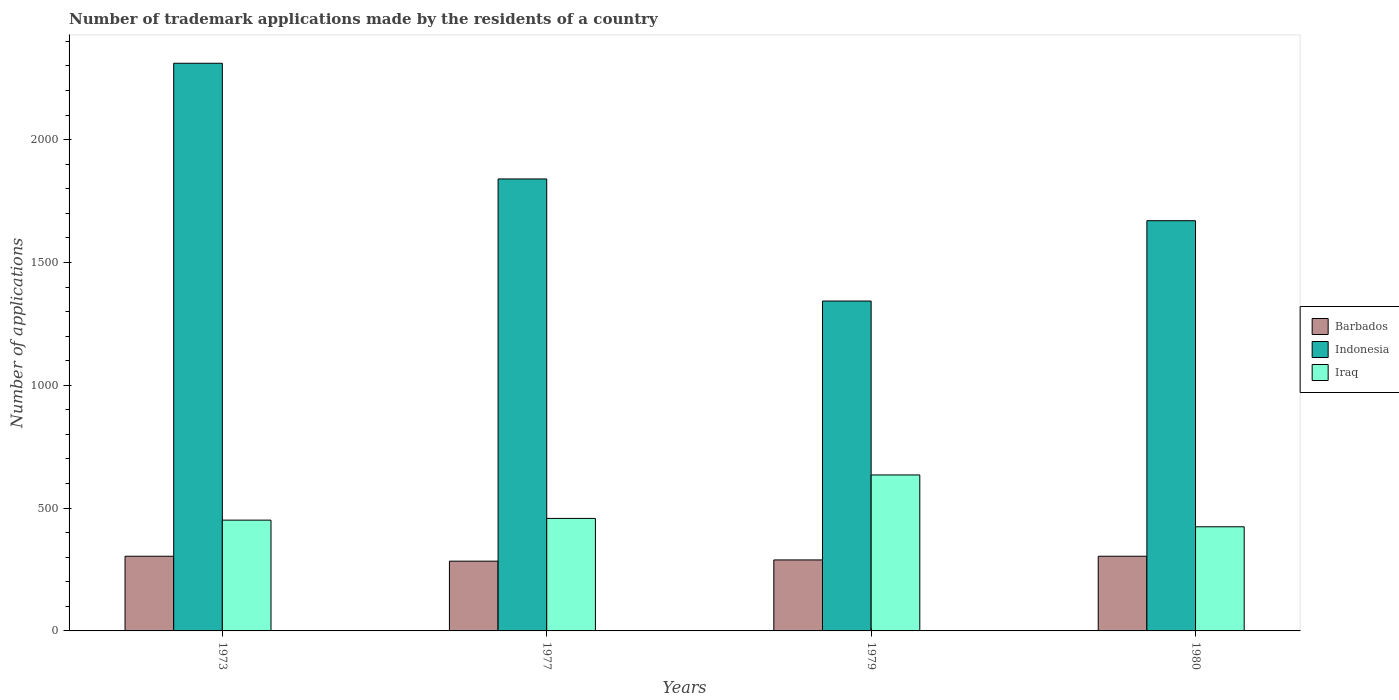How many different coloured bars are there?
Offer a terse response. 3. Are the number of bars on each tick of the X-axis equal?
Provide a succinct answer. Yes. How many bars are there on the 1st tick from the left?
Your answer should be very brief. 3. How many bars are there on the 1st tick from the right?
Keep it short and to the point. 3. What is the label of the 4th group of bars from the left?
Make the answer very short. 1980. What is the number of trademark applications made by the residents in Barbados in 1979?
Provide a succinct answer. 289. Across all years, what is the maximum number of trademark applications made by the residents in Indonesia?
Offer a very short reply. 2311. Across all years, what is the minimum number of trademark applications made by the residents in Indonesia?
Your response must be concise. 1343. In which year was the number of trademark applications made by the residents in Iraq maximum?
Your response must be concise. 1979. What is the total number of trademark applications made by the residents in Iraq in the graph?
Keep it short and to the point. 1968. What is the difference between the number of trademark applications made by the residents in Indonesia in 1977 and that in 1979?
Your answer should be very brief. 497. What is the difference between the number of trademark applications made by the residents in Indonesia in 1977 and the number of trademark applications made by the residents in Barbados in 1973?
Give a very brief answer. 1536. What is the average number of trademark applications made by the residents in Indonesia per year?
Offer a very short reply. 1791. In the year 1973, what is the difference between the number of trademark applications made by the residents in Indonesia and number of trademark applications made by the residents in Barbados?
Ensure brevity in your answer.  2007. In how many years, is the number of trademark applications made by the residents in Iraq greater than 1500?
Keep it short and to the point. 0. What is the ratio of the number of trademark applications made by the residents in Iraq in 1973 to that in 1979?
Provide a succinct answer. 0.71. What is the difference between the highest and the second highest number of trademark applications made by the residents in Indonesia?
Ensure brevity in your answer.  471. What is the difference between the highest and the lowest number of trademark applications made by the residents in Barbados?
Make the answer very short. 20. In how many years, is the number of trademark applications made by the residents in Indonesia greater than the average number of trademark applications made by the residents in Indonesia taken over all years?
Provide a succinct answer. 2. What does the 3rd bar from the left in 1980 represents?
Provide a succinct answer. Iraq. Are all the bars in the graph horizontal?
Your answer should be very brief. No. How many years are there in the graph?
Provide a short and direct response. 4. What is the difference between two consecutive major ticks on the Y-axis?
Ensure brevity in your answer.  500. Are the values on the major ticks of Y-axis written in scientific E-notation?
Your answer should be very brief. No. How many legend labels are there?
Your answer should be very brief. 3. What is the title of the graph?
Offer a terse response. Number of trademark applications made by the residents of a country. Does "Micronesia" appear as one of the legend labels in the graph?
Provide a succinct answer. No. What is the label or title of the Y-axis?
Offer a very short reply. Number of applications. What is the Number of applications of Barbados in 1973?
Your answer should be very brief. 304. What is the Number of applications of Indonesia in 1973?
Provide a succinct answer. 2311. What is the Number of applications of Iraq in 1973?
Provide a succinct answer. 451. What is the Number of applications of Barbados in 1977?
Your answer should be compact. 284. What is the Number of applications of Indonesia in 1977?
Ensure brevity in your answer.  1840. What is the Number of applications in Iraq in 1977?
Offer a terse response. 458. What is the Number of applications of Barbados in 1979?
Offer a terse response. 289. What is the Number of applications of Indonesia in 1979?
Your answer should be very brief. 1343. What is the Number of applications of Iraq in 1979?
Keep it short and to the point. 635. What is the Number of applications in Barbados in 1980?
Your answer should be compact. 304. What is the Number of applications of Indonesia in 1980?
Give a very brief answer. 1670. What is the Number of applications in Iraq in 1980?
Offer a terse response. 424. Across all years, what is the maximum Number of applications of Barbados?
Your answer should be compact. 304. Across all years, what is the maximum Number of applications in Indonesia?
Give a very brief answer. 2311. Across all years, what is the maximum Number of applications of Iraq?
Provide a short and direct response. 635. Across all years, what is the minimum Number of applications in Barbados?
Give a very brief answer. 284. Across all years, what is the minimum Number of applications of Indonesia?
Ensure brevity in your answer.  1343. Across all years, what is the minimum Number of applications in Iraq?
Keep it short and to the point. 424. What is the total Number of applications in Barbados in the graph?
Give a very brief answer. 1181. What is the total Number of applications of Indonesia in the graph?
Offer a terse response. 7164. What is the total Number of applications of Iraq in the graph?
Your answer should be compact. 1968. What is the difference between the Number of applications of Indonesia in 1973 and that in 1977?
Your answer should be very brief. 471. What is the difference between the Number of applications of Iraq in 1973 and that in 1977?
Make the answer very short. -7. What is the difference between the Number of applications in Indonesia in 1973 and that in 1979?
Ensure brevity in your answer.  968. What is the difference between the Number of applications of Iraq in 1973 and that in 1979?
Ensure brevity in your answer.  -184. What is the difference between the Number of applications in Indonesia in 1973 and that in 1980?
Your response must be concise. 641. What is the difference between the Number of applications in Barbados in 1977 and that in 1979?
Your answer should be very brief. -5. What is the difference between the Number of applications of Indonesia in 1977 and that in 1979?
Your answer should be very brief. 497. What is the difference between the Number of applications in Iraq in 1977 and that in 1979?
Keep it short and to the point. -177. What is the difference between the Number of applications in Indonesia in 1977 and that in 1980?
Make the answer very short. 170. What is the difference between the Number of applications in Barbados in 1979 and that in 1980?
Your answer should be very brief. -15. What is the difference between the Number of applications of Indonesia in 1979 and that in 1980?
Your response must be concise. -327. What is the difference between the Number of applications in Iraq in 1979 and that in 1980?
Give a very brief answer. 211. What is the difference between the Number of applications in Barbados in 1973 and the Number of applications in Indonesia in 1977?
Ensure brevity in your answer.  -1536. What is the difference between the Number of applications of Barbados in 1973 and the Number of applications of Iraq in 1977?
Ensure brevity in your answer.  -154. What is the difference between the Number of applications of Indonesia in 1973 and the Number of applications of Iraq in 1977?
Provide a short and direct response. 1853. What is the difference between the Number of applications of Barbados in 1973 and the Number of applications of Indonesia in 1979?
Make the answer very short. -1039. What is the difference between the Number of applications of Barbados in 1973 and the Number of applications of Iraq in 1979?
Make the answer very short. -331. What is the difference between the Number of applications in Indonesia in 1973 and the Number of applications in Iraq in 1979?
Your answer should be compact. 1676. What is the difference between the Number of applications of Barbados in 1973 and the Number of applications of Indonesia in 1980?
Provide a succinct answer. -1366. What is the difference between the Number of applications in Barbados in 1973 and the Number of applications in Iraq in 1980?
Offer a terse response. -120. What is the difference between the Number of applications of Indonesia in 1973 and the Number of applications of Iraq in 1980?
Offer a terse response. 1887. What is the difference between the Number of applications of Barbados in 1977 and the Number of applications of Indonesia in 1979?
Offer a very short reply. -1059. What is the difference between the Number of applications of Barbados in 1977 and the Number of applications of Iraq in 1979?
Your response must be concise. -351. What is the difference between the Number of applications of Indonesia in 1977 and the Number of applications of Iraq in 1979?
Keep it short and to the point. 1205. What is the difference between the Number of applications in Barbados in 1977 and the Number of applications in Indonesia in 1980?
Offer a very short reply. -1386. What is the difference between the Number of applications of Barbados in 1977 and the Number of applications of Iraq in 1980?
Your response must be concise. -140. What is the difference between the Number of applications in Indonesia in 1977 and the Number of applications in Iraq in 1980?
Your response must be concise. 1416. What is the difference between the Number of applications in Barbados in 1979 and the Number of applications in Indonesia in 1980?
Ensure brevity in your answer.  -1381. What is the difference between the Number of applications in Barbados in 1979 and the Number of applications in Iraq in 1980?
Offer a very short reply. -135. What is the difference between the Number of applications in Indonesia in 1979 and the Number of applications in Iraq in 1980?
Make the answer very short. 919. What is the average Number of applications in Barbados per year?
Ensure brevity in your answer.  295.25. What is the average Number of applications in Indonesia per year?
Give a very brief answer. 1791. What is the average Number of applications in Iraq per year?
Your answer should be compact. 492. In the year 1973, what is the difference between the Number of applications of Barbados and Number of applications of Indonesia?
Your answer should be very brief. -2007. In the year 1973, what is the difference between the Number of applications of Barbados and Number of applications of Iraq?
Your response must be concise. -147. In the year 1973, what is the difference between the Number of applications in Indonesia and Number of applications in Iraq?
Give a very brief answer. 1860. In the year 1977, what is the difference between the Number of applications of Barbados and Number of applications of Indonesia?
Your response must be concise. -1556. In the year 1977, what is the difference between the Number of applications of Barbados and Number of applications of Iraq?
Keep it short and to the point. -174. In the year 1977, what is the difference between the Number of applications in Indonesia and Number of applications in Iraq?
Provide a succinct answer. 1382. In the year 1979, what is the difference between the Number of applications in Barbados and Number of applications in Indonesia?
Ensure brevity in your answer.  -1054. In the year 1979, what is the difference between the Number of applications in Barbados and Number of applications in Iraq?
Your response must be concise. -346. In the year 1979, what is the difference between the Number of applications of Indonesia and Number of applications of Iraq?
Offer a very short reply. 708. In the year 1980, what is the difference between the Number of applications of Barbados and Number of applications of Indonesia?
Provide a short and direct response. -1366. In the year 1980, what is the difference between the Number of applications of Barbados and Number of applications of Iraq?
Your answer should be very brief. -120. In the year 1980, what is the difference between the Number of applications in Indonesia and Number of applications in Iraq?
Your answer should be very brief. 1246. What is the ratio of the Number of applications in Barbados in 1973 to that in 1977?
Offer a terse response. 1.07. What is the ratio of the Number of applications of Indonesia in 1973 to that in 1977?
Make the answer very short. 1.26. What is the ratio of the Number of applications in Iraq in 1973 to that in 1977?
Ensure brevity in your answer.  0.98. What is the ratio of the Number of applications of Barbados in 1973 to that in 1979?
Ensure brevity in your answer.  1.05. What is the ratio of the Number of applications of Indonesia in 1973 to that in 1979?
Ensure brevity in your answer.  1.72. What is the ratio of the Number of applications of Iraq in 1973 to that in 1979?
Give a very brief answer. 0.71. What is the ratio of the Number of applications of Barbados in 1973 to that in 1980?
Keep it short and to the point. 1. What is the ratio of the Number of applications of Indonesia in 1973 to that in 1980?
Provide a short and direct response. 1.38. What is the ratio of the Number of applications of Iraq in 1973 to that in 1980?
Your response must be concise. 1.06. What is the ratio of the Number of applications of Barbados in 1977 to that in 1979?
Your answer should be very brief. 0.98. What is the ratio of the Number of applications of Indonesia in 1977 to that in 1979?
Ensure brevity in your answer.  1.37. What is the ratio of the Number of applications of Iraq in 1977 to that in 1979?
Offer a very short reply. 0.72. What is the ratio of the Number of applications in Barbados in 1977 to that in 1980?
Provide a succinct answer. 0.93. What is the ratio of the Number of applications of Indonesia in 1977 to that in 1980?
Provide a short and direct response. 1.1. What is the ratio of the Number of applications in Iraq in 1977 to that in 1980?
Your answer should be compact. 1.08. What is the ratio of the Number of applications in Barbados in 1979 to that in 1980?
Provide a succinct answer. 0.95. What is the ratio of the Number of applications of Indonesia in 1979 to that in 1980?
Keep it short and to the point. 0.8. What is the ratio of the Number of applications of Iraq in 1979 to that in 1980?
Offer a terse response. 1.5. What is the difference between the highest and the second highest Number of applications of Barbados?
Your answer should be compact. 0. What is the difference between the highest and the second highest Number of applications of Indonesia?
Keep it short and to the point. 471. What is the difference between the highest and the second highest Number of applications of Iraq?
Offer a very short reply. 177. What is the difference between the highest and the lowest Number of applications of Barbados?
Keep it short and to the point. 20. What is the difference between the highest and the lowest Number of applications of Indonesia?
Your answer should be compact. 968. What is the difference between the highest and the lowest Number of applications in Iraq?
Your answer should be very brief. 211. 